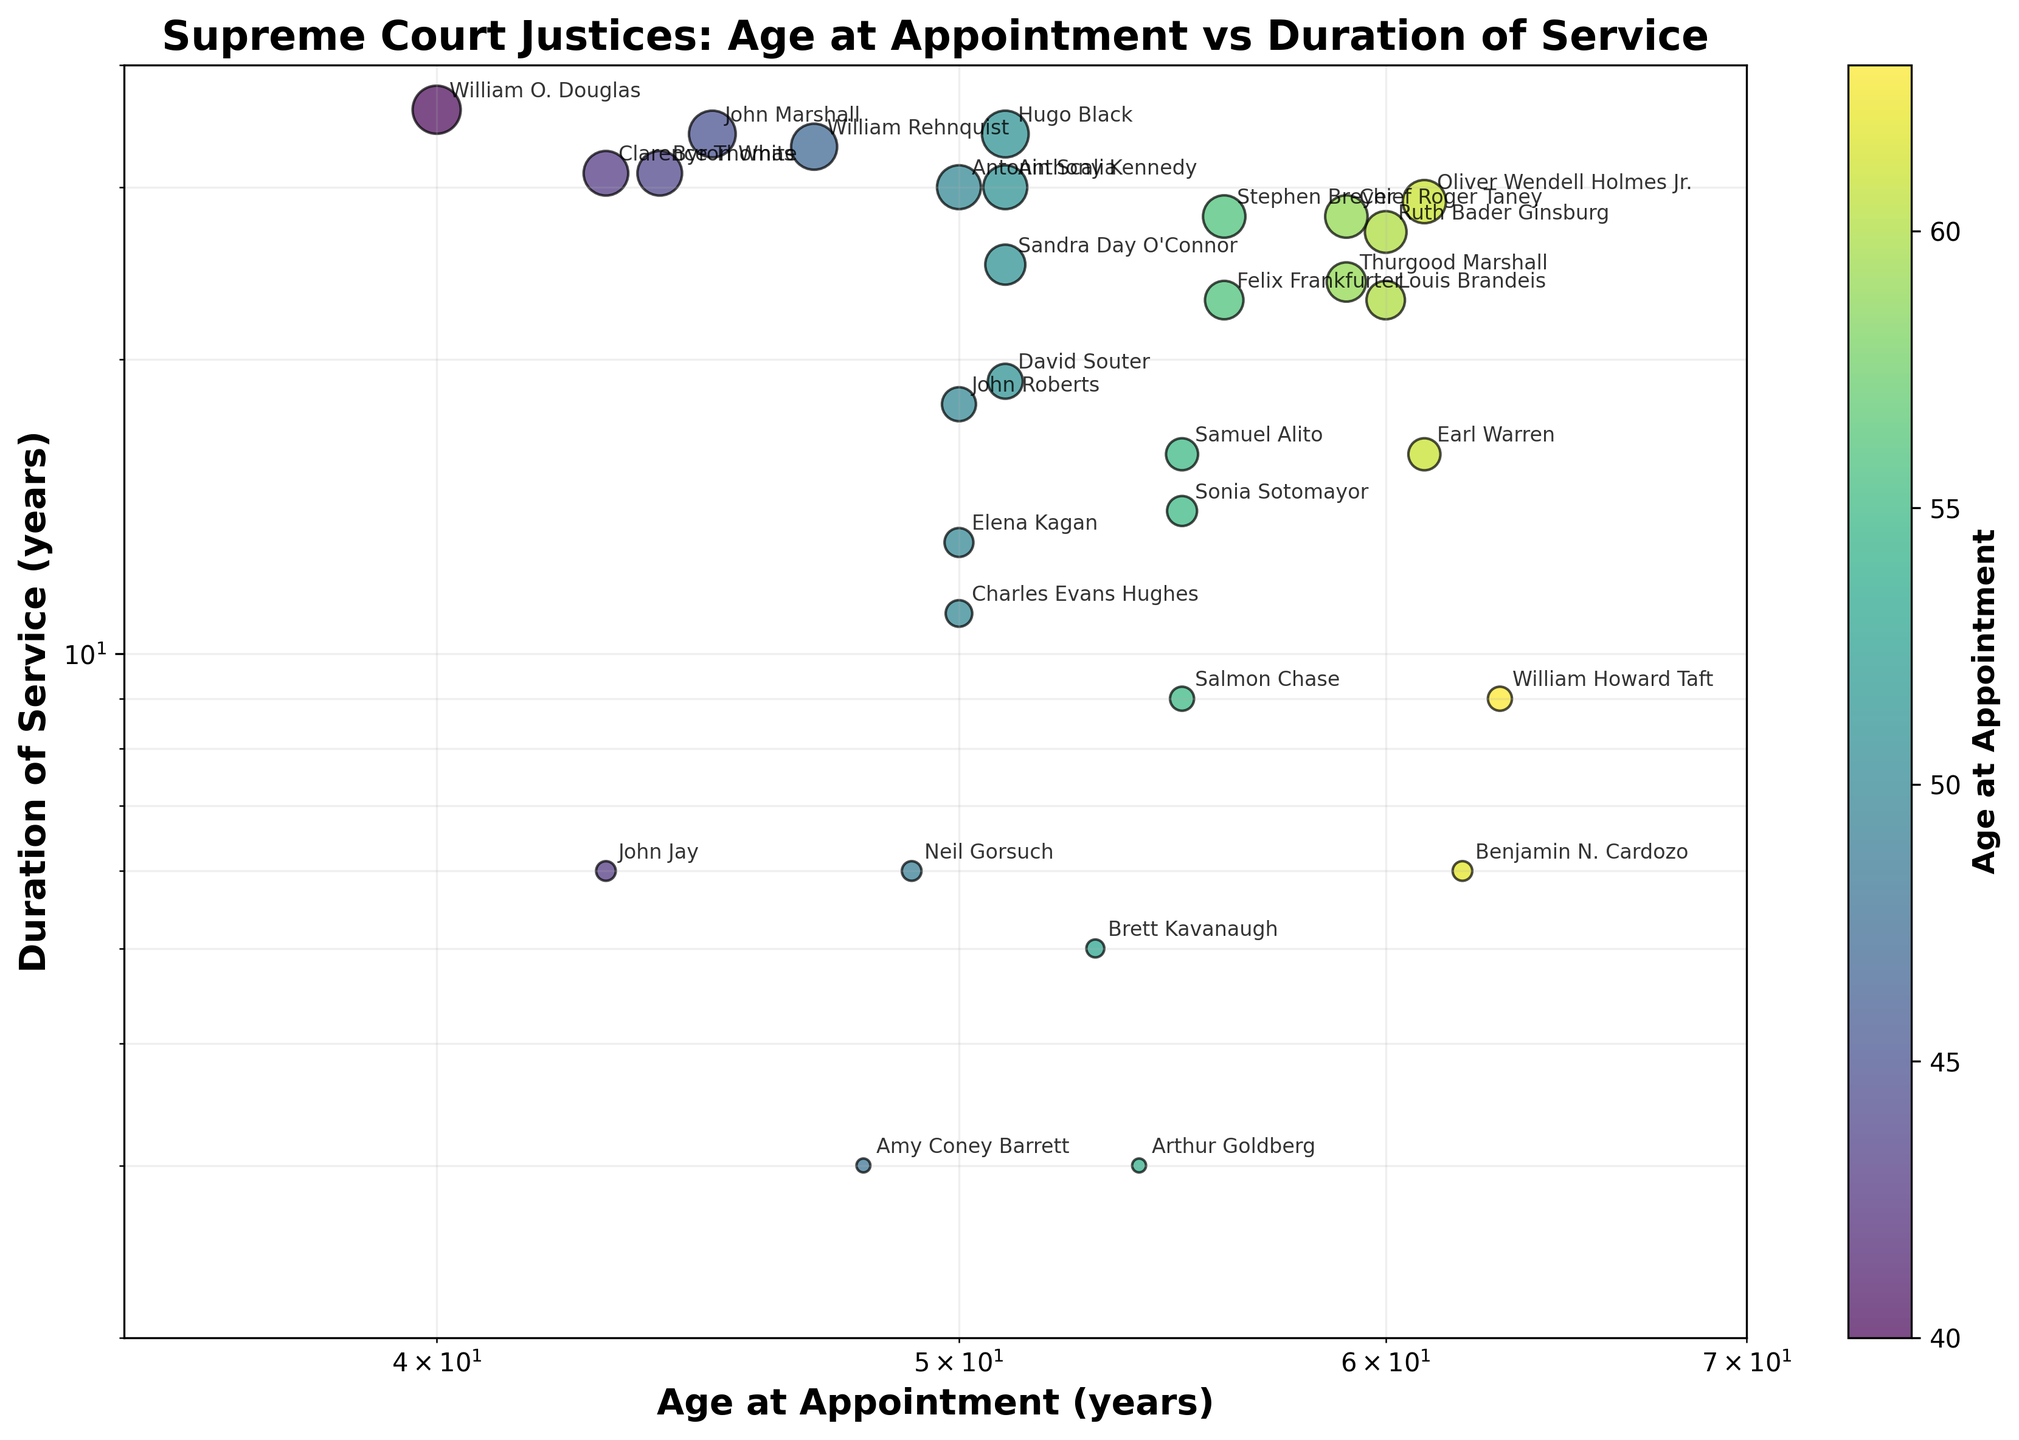What is the title of the scatter plot? The title of a plot is usually displayed at the top of the figure. In this case, it reads: "Supreme Court Justices: Age at Appointment vs Duration of Service"
Answer: Supreme Court Justices: Age at Appointment vs Duration of Service What are the x and y axes representing in the scatter plot? The x-axis is labeled "Age at Appointment (years)" and the y-axis is labeled "Duration of Service (years)". These labels indicate what each axis represents.
Answer: Age at Appointment (years) and Duration of Service (years) Which justice served the longest term and what was their age at appointment? By examining the data points, we look for the point that is highest on the y-axis, indicating the longest service duration. This corresponds to William O. Douglas, who served for 36 years and was appointed at age 40.
Answer: William O. Douglas, 40 years old Who was the youngest justice at the time of appointment and how long did they serve? To find the youngest justice, locate the point furthest left on the x-axis, which represents the lowest age. This corresponds to William O. Douglas, who was 40 at appointment and served for 36 years.
Answer: William O. Douglas, 36 years What is the color and size of the data point for Justice Sonia Sotomayor? The color in the scatter plot represents the age at appointment and size represents the duration of service. Sonia Sotomayor was appointed at age 55, and served for 14 years. This would correlate with the appropriate color on the color bar for age 55, and a point size correlated to 14 years
Answer: Age 55 color, 14 years size Which justice had the shortest duration of service and what was their age at appointment? To determine the shortest service duration, look for the data point lowest on the y-axis. This corresponds to Amy Coney Barrett, who has the smallest duration of 3 years and was appointed at age 48.
Answer: Amy Coney Barrett, 48 years old How many justices were appointed at an age older than 55 years? Examine the scatter plot and count the number of data points to the right of the age value (greater than 55) on the x-axis. These data points are for Oliver Wendell Holmes Jr., Louis Brandeis, Thurgood Marshall, Ruth Bader Ginsburg, Sonia Sotomayor, Samuel Alito, Charles Evans Hughes, and William Howard Taft. So there are 8 justices in total.
Answer: 8 What is the relationship between age at appointment and duration of service for John Marshall and Hugo Black? First, identify the points for John Marshall (appointed at age 45, served 34 years) and Hugo Black (appointed at age 51, served 34 years). Then compare their ages and durations. Both served for 34 years, suggesting no direct relationship in this case for service duration despite different ages at appointment.
Answer: Both served 34 years How does the duration of service for Clarence Thomas compare with that of Byron White? Clarence Thomas served for 31 years after being appointed at 43 years old, while Byron White also served for 31 years after being appointed at age 44. Both justices served for the same duration of time.
Answer: Both served for 31 years Who were the justices appointed at age 51 and what were their durations of service? Identify all data points at the age value 51 on the x-axis. These correspond to Hugo Black (34 years), Sandra Day O'Connor (25 years), David Souter (19 years), and Anthony Kennedy (30 years).
Answer: Hugo Black (34 years), Sandra Day O'Connor (25 years), David Souter (19 years), Anthony Kennedy (30 years) 